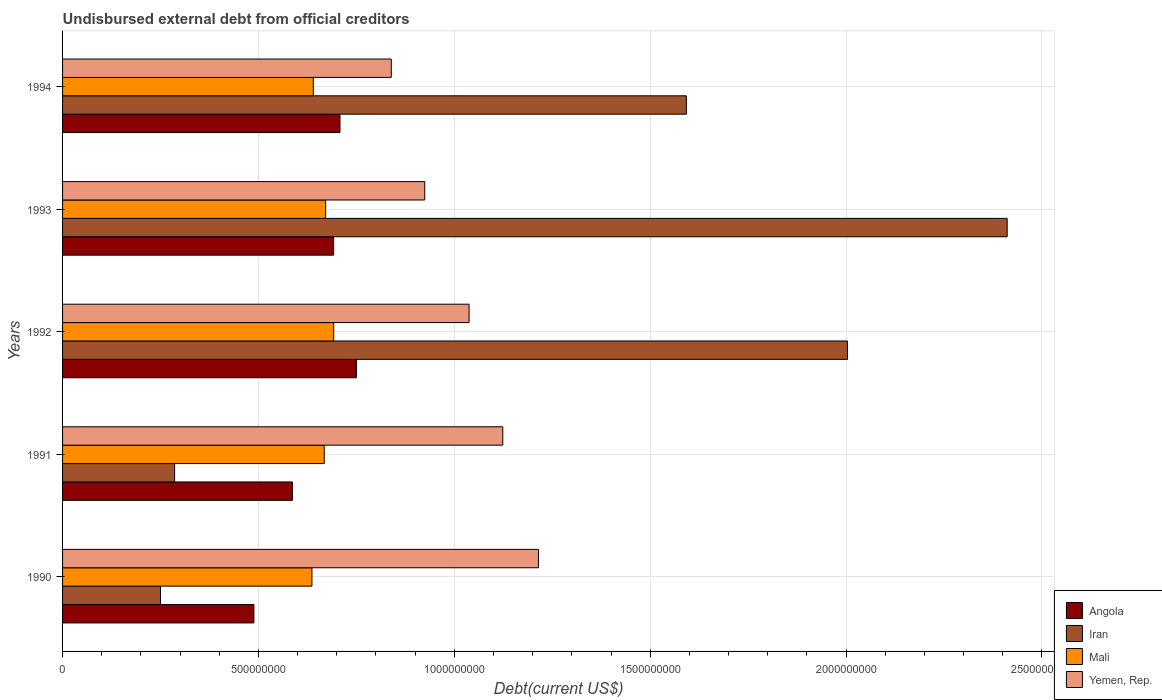How many different coloured bars are there?
Give a very brief answer. 4. How many groups of bars are there?
Make the answer very short. 5. How many bars are there on the 4th tick from the top?
Keep it short and to the point. 4. How many bars are there on the 3rd tick from the bottom?
Your answer should be very brief. 4. What is the label of the 4th group of bars from the top?
Your answer should be compact. 1991. What is the total debt in Mali in 1994?
Your answer should be compact. 6.40e+08. Across all years, what is the maximum total debt in Angola?
Your response must be concise. 7.50e+08. Across all years, what is the minimum total debt in Iran?
Ensure brevity in your answer.  2.50e+08. In which year was the total debt in Angola minimum?
Your answer should be very brief. 1990. What is the total total debt in Yemen, Rep. in the graph?
Give a very brief answer. 5.14e+09. What is the difference between the total debt in Iran in 1990 and that in 1993?
Keep it short and to the point. -2.16e+09. What is the difference between the total debt in Angola in 1992 and the total debt in Yemen, Rep. in 1991?
Make the answer very short. -3.74e+08. What is the average total debt in Angola per year?
Keep it short and to the point. 6.45e+08. In the year 1992, what is the difference between the total debt in Mali and total debt in Angola?
Provide a succinct answer. -5.78e+07. What is the ratio of the total debt in Iran in 1990 to that in 1991?
Offer a terse response. 0.87. Is the total debt in Mali in 1992 less than that in 1993?
Ensure brevity in your answer.  No. Is the difference between the total debt in Mali in 1991 and 1992 greater than the difference between the total debt in Angola in 1991 and 1992?
Offer a very short reply. Yes. What is the difference between the highest and the second highest total debt in Angola?
Your answer should be compact. 4.18e+07. What is the difference between the highest and the lowest total debt in Mali?
Ensure brevity in your answer.  5.56e+07. Is the sum of the total debt in Yemen, Rep. in 1990 and 1992 greater than the maximum total debt in Angola across all years?
Ensure brevity in your answer.  Yes. What does the 1st bar from the top in 1994 represents?
Offer a terse response. Yemen, Rep. What does the 1st bar from the bottom in 1991 represents?
Provide a short and direct response. Angola. Is it the case that in every year, the sum of the total debt in Angola and total debt in Yemen, Rep. is greater than the total debt in Iran?
Offer a terse response. No. How many bars are there?
Your response must be concise. 20. How many years are there in the graph?
Your response must be concise. 5. What is the difference between two consecutive major ticks on the X-axis?
Make the answer very short. 5.00e+08. Are the values on the major ticks of X-axis written in scientific E-notation?
Your answer should be compact. No. Does the graph contain any zero values?
Give a very brief answer. No. Does the graph contain grids?
Offer a terse response. Yes. Where does the legend appear in the graph?
Ensure brevity in your answer.  Bottom right. How are the legend labels stacked?
Keep it short and to the point. Vertical. What is the title of the graph?
Offer a very short reply. Undisbursed external debt from official creditors. Does "Equatorial Guinea" appear as one of the legend labels in the graph?
Offer a very short reply. No. What is the label or title of the X-axis?
Provide a succinct answer. Debt(current US$). What is the label or title of the Y-axis?
Your answer should be compact. Years. What is the Debt(current US$) in Angola in 1990?
Keep it short and to the point. 4.88e+08. What is the Debt(current US$) in Iran in 1990?
Provide a succinct answer. 2.50e+08. What is the Debt(current US$) in Mali in 1990?
Your answer should be compact. 6.37e+08. What is the Debt(current US$) in Yemen, Rep. in 1990?
Make the answer very short. 1.21e+09. What is the Debt(current US$) in Angola in 1991?
Offer a very short reply. 5.87e+08. What is the Debt(current US$) in Iran in 1991?
Offer a very short reply. 2.86e+08. What is the Debt(current US$) in Mali in 1991?
Offer a very short reply. 6.68e+08. What is the Debt(current US$) of Yemen, Rep. in 1991?
Your response must be concise. 1.12e+09. What is the Debt(current US$) in Angola in 1992?
Your answer should be very brief. 7.50e+08. What is the Debt(current US$) in Iran in 1992?
Offer a terse response. 2.00e+09. What is the Debt(current US$) of Mali in 1992?
Provide a succinct answer. 6.92e+08. What is the Debt(current US$) of Yemen, Rep. in 1992?
Make the answer very short. 1.04e+09. What is the Debt(current US$) in Angola in 1993?
Offer a terse response. 6.92e+08. What is the Debt(current US$) of Iran in 1993?
Keep it short and to the point. 2.41e+09. What is the Debt(current US$) of Mali in 1993?
Keep it short and to the point. 6.72e+08. What is the Debt(current US$) in Yemen, Rep. in 1993?
Make the answer very short. 9.25e+08. What is the Debt(current US$) in Angola in 1994?
Offer a very short reply. 7.08e+08. What is the Debt(current US$) in Iran in 1994?
Offer a very short reply. 1.59e+09. What is the Debt(current US$) of Mali in 1994?
Your answer should be very brief. 6.40e+08. What is the Debt(current US$) of Yemen, Rep. in 1994?
Your response must be concise. 8.39e+08. Across all years, what is the maximum Debt(current US$) of Angola?
Make the answer very short. 7.50e+08. Across all years, what is the maximum Debt(current US$) of Iran?
Give a very brief answer. 2.41e+09. Across all years, what is the maximum Debt(current US$) of Mali?
Ensure brevity in your answer.  6.92e+08. Across all years, what is the maximum Debt(current US$) of Yemen, Rep.?
Provide a short and direct response. 1.21e+09. Across all years, what is the minimum Debt(current US$) of Angola?
Keep it short and to the point. 4.88e+08. Across all years, what is the minimum Debt(current US$) in Iran?
Offer a terse response. 2.50e+08. Across all years, what is the minimum Debt(current US$) in Mali?
Your answer should be compact. 6.37e+08. Across all years, what is the minimum Debt(current US$) of Yemen, Rep.?
Provide a short and direct response. 8.39e+08. What is the total Debt(current US$) of Angola in the graph?
Your answer should be very brief. 3.22e+09. What is the total Debt(current US$) in Iran in the graph?
Give a very brief answer. 6.54e+09. What is the total Debt(current US$) in Mali in the graph?
Your answer should be compact. 3.31e+09. What is the total Debt(current US$) in Yemen, Rep. in the graph?
Make the answer very short. 5.14e+09. What is the difference between the Debt(current US$) of Angola in 1990 and that in 1991?
Provide a succinct answer. -9.83e+07. What is the difference between the Debt(current US$) of Iran in 1990 and that in 1991?
Give a very brief answer. -3.60e+07. What is the difference between the Debt(current US$) in Mali in 1990 and that in 1991?
Ensure brevity in your answer.  -3.14e+07. What is the difference between the Debt(current US$) of Yemen, Rep. in 1990 and that in 1991?
Your answer should be compact. 9.11e+07. What is the difference between the Debt(current US$) in Angola in 1990 and that in 1992?
Give a very brief answer. -2.62e+08. What is the difference between the Debt(current US$) of Iran in 1990 and that in 1992?
Your response must be concise. -1.75e+09. What is the difference between the Debt(current US$) in Mali in 1990 and that in 1992?
Offer a terse response. -5.56e+07. What is the difference between the Debt(current US$) of Yemen, Rep. in 1990 and that in 1992?
Your answer should be compact. 1.77e+08. What is the difference between the Debt(current US$) of Angola in 1990 and that in 1993?
Provide a succinct answer. -2.03e+08. What is the difference between the Debt(current US$) of Iran in 1990 and that in 1993?
Offer a very short reply. -2.16e+09. What is the difference between the Debt(current US$) in Mali in 1990 and that in 1993?
Offer a terse response. -3.50e+07. What is the difference between the Debt(current US$) of Yemen, Rep. in 1990 and that in 1993?
Your response must be concise. 2.90e+08. What is the difference between the Debt(current US$) in Angola in 1990 and that in 1994?
Give a very brief answer. -2.20e+08. What is the difference between the Debt(current US$) in Iran in 1990 and that in 1994?
Your answer should be very brief. -1.34e+09. What is the difference between the Debt(current US$) in Mali in 1990 and that in 1994?
Your answer should be compact. -3.48e+06. What is the difference between the Debt(current US$) of Yemen, Rep. in 1990 and that in 1994?
Offer a terse response. 3.76e+08. What is the difference between the Debt(current US$) in Angola in 1991 and that in 1992?
Your answer should be very brief. -1.63e+08. What is the difference between the Debt(current US$) in Iran in 1991 and that in 1992?
Make the answer very short. -1.72e+09. What is the difference between the Debt(current US$) in Mali in 1991 and that in 1992?
Keep it short and to the point. -2.41e+07. What is the difference between the Debt(current US$) in Yemen, Rep. in 1991 and that in 1992?
Offer a terse response. 8.60e+07. What is the difference between the Debt(current US$) of Angola in 1991 and that in 1993?
Offer a very short reply. -1.05e+08. What is the difference between the Debt(current US$) in Iran in 1991 and that in 1993?
Offer a very short reply. -2.13e+09. What is the difference between the Debt(current US$) in Mali in 1991 and that in 1993?
Your answer should be very brief. -3.56e+06. What is the difference between the Debt(current US$) of Yemen, Rep. in 1991 and that in 1993?
Ensure brevity in your answer.  1.99e+08. What is the difference between the Debt(current US$) in Angola in 1991 and that in 1994?
Your answer should be compact. -1.21e+08. What is the difference between the Debt(current US$) in Iran in 1991 and that in 1994?
Give a very brief answer. -1.31e+09. What is the difference between the Debt(current US$) of Mali in 1991 and that in 1994?
Ensure brevity in your answer.  2.80e+07. What is the difference between the Debt(current US$) in Yemen, Rep. in 1991 and that in 1994?
Your answer should be compact. 2.85e+08. What is the difference between the Debt(current US$) in Angola in 1992 and that in 1993?
Offer a terse response. 5.81e+07. What is the difference between the Debt(current US$) of Iran in 1992 and that in 1993?
Ensure brevity in your answer.  -4.08e+08. What is the difference between the Debt(current US$) of Mali in 1992 and that in 1993?
Provide a succinct answer. 2.06e+07. What is the difference between the Debt(current US$) of Yemen, Rep. in 1992 and that in 1993?
Give a very brief answer. 1.13e+08. What is the difference between the Debt(current US$) in Angola in 1992 and that in 1994?
Give a very brief answer. 4.18e+07. What is the difference between the Debt(current US$) in Iran in 1992 and that in 1994?
Give a very brief answer. 4.11e+08. What is the difference between the Debt(current US$) in Mali in 1992 and that in 1994?
Your answer should be very brief. 5.21e+07. What is the difference between the Debt(current US$) of Yemen, Rep. in 1992 and that in 1994?
Give a very brief answer. 1.99e+08. What is the difference between the Debt(current US$) of Angola in 1993 and that in 1994?
Provide a succinct answer. -1.63e+07. What is the difference between the Debt(current US$) of Iran in 1993 and that in 1994?
Give a very brief answer. 8.19e+08. What is the difference between the Debt(current US$) in Mali in 1993 and that in 1994?
Offer a terse response. 3.15e+07. What is the difference between the Debt(current US$) in Yemen, Rep. in 1993 and that in 1994?
Ensure brevity in your answer.  8.55e+07. What is the difference between the Debt(current US$) in Angola in 1990 and the Debt(current US$) in Iran in 1991?
Offer a very short reply. 2.02e+08. What is the difference between the Debt(current US$) in Angola in 1990 and the Debt(current US$) in Mali in 1991?
Make the answer very short. -1.80e+08. What is the difference between the Debt(current US$) in Angola in 1990 and the Debt(current US$) in Yemen, Rep. in 1991?
Make the answer very short. -6.35e+08. What is the difference between the Debt(current US$) of Iran in 1990 and the Debt(current US$) of Mali in 1991?
Your response must be concise. -4.18e+08. What is the difference between the Debt(current US$) in Iran in 1990 and the Debt(current US$) in Yemen, Rep. in 1991?
Your response must be concise. -8.74e+08. What is the difference between the Debt(current US$) in Mali in 1990 and the Debt(current US$) in Yemen, Rep. in 1991?
Keep it short and to the point. -4.87e+08. What is the difference between the Debt(current US$) of Angola in 1990 and the Debt(current US$) of Iran in 1992?
Give a very brief answer. -1.52e+09. What is the difference between the Debt(current US$) in Angola in 1990 and the Debt(current US$) in Mali in 1992?
Offer a terse response. -2.04e+08. What is the difference between the Debt(current US$) of Angola in 1990 and the Debt(current US$) of Yemen, Rep. in 1992?
Offer a very short reply. -5.49e+08. What is the difference between the Debt(current US$) in Iran in 1990 and the Debt(current US$) in Mali in 1992?
Offer a very short reply. -4.42e+08. What is the difference between the Debt(current US$) in Iran in 1990 and the Debt(current US$) in Yemen, Rep. in 1992?
Provide a succinct answer. -7.88e+08. What is the difference between the Debt(current US$) of Mali in 1990 and the Debt(current US$) of Yemen, Rep. in 1992?
Provide a succinct answer. -4.01e+08. What is the difference between the Debt(current US$) in Angola in 1990 and the Debt(current US$) in Iran in 1993?
Provide a short and direct response. -1.92e+09. What is the difference between the Debt(current US$) of Angola in 1990 and the Debt(current US$) of Mali in 1993?
Offer a terse response. -1.83e+08. What is the difference between the Debt(current US$) in Angola in 1990 and the Debt(current US$) in Yemen, Rep. in 1993?
Offer a terse response. -4.36e+08. What is the difference between the Debt(current US$) of Iran in 1990 and the Debt(current US$) of Mali in 1993?
Give a very brief answer. -4.22e+08. What is the difference between the Debt(current US$) in Iran in 1990 and the Debt(current US$) in Yemen, Rep. in 1993?
Provide a short and direct response. -6.75e+08. What is the difference between the Debt(current US$) of Mali in 1990 and the Debt(current US$) of Yemen, Rep. in 1993?
Offer a very short reply. -2.88e+08. What is the difference between the Debt(current US$) in Angola in 1990 and the Debt(current US$) in Iran in 1994?
Your answer should be compact. -1.10e+09. What is the difference between the Debt(current US$) in Angola in 1990 and the Debt(current US$) in Mali in 1994?
Offer a terse response. -1.52e+08. What is the difference between the Debt(current US$) of Angola in 1990 and the Debt(current US$) of Yemen, Rep. in 1994?
Make the answer very short. -3.51e+08. What is the difference between the Debt(current US$) of Iran in 1990 and the Debt(current US$) of Mali in 1994?
Ensure brevity in your answer.  -3.90e+08. What is the difference between the Debt(current US$) in Iran in 1990 and the Debt(current US$) in Yemen, Rep. in 1994?
Make the answer very short. -5.89e+08. What is the difference between the Debt(current US$) of Mali in 1990 and the Debt(current US$) of Yemen, Rep. in 1994?
Keep it short and to the point. -2.03e+08. What is the difference between the Debt(current US$) in Angola in 1991 and the Debt(current US$) in Iran in 1992?
Give a very brief answer. -1.42e+09. What is the difference between the Debt(current US$) in Angola in 1991 and the Debt(current US$) in Mali in 1992?
Ensure brevity in your answer.  -1.05e+08. What is the difference between the Debt(current US$) of Angola in 1991 and the Debt(current US$) of Yemen, Rep. in 1992?
Offer a terse response. -4.51e+08. What is the difference between the Debt(current US$) of Iran in 1991 and the Debt(current US$) of Mali in 1992?
Your answer should be very brief. -4.06e+08. What is the difference between the Debt(current US$) in Iran in 1991 and the Debt(current US$) in Yemen, Rep. in 1992?
Your answer should be compact. -7.52e+08. What is the difference between the Debt(current US$) in Mali in 1991 and the Debt(current US$) in Yemen, Rep. in 1992?
Your response must be concise. -3.70e+08. What is the difference between the Debt(current US$) of Angola in 1991 and the Debt(current US$) of Iran in 1993?
Your answer should be compact. -1.82e+09. What is the difference between the Debt(current US$) of Angola in 1991 and the Debt(current US$) of Mali in 1993?
Offer a very short reply. -8.48e+07. What is the difference between the Debt(current US$) of Angola in 1991 and the Debt(current US$) of Yemen, Rep. in 1993?
Offer a terse response. -3.38e+08. What is the difference between the Debt(current US$) in Iran in 1991 and the Debt(current US$) in Mali in 1993?
Your response must be concise. -3.86e+08. What is the difference between the Debt(current US$) of Iran in 1991 and the Debt(current US$) of Yemen, Rep. in 1993?
Keep it short and to the point. -6.39e+08. What is the difference between the Debt(current US$) in Mali in 1991 and the Debt(current US$) in Yemen, Rep. in 1993?
Your response must be concise. -2.57e+08. What is the difference between the Debt(current US$) of Angola in 1991 and the Debt(current US$) of Iran in 1994?
Offer a terse response. -1.01e+09. What is the difference between the Debt(current US$) in Angola in 1991 and the Debt(current US$) in Mali in 1994?
Your answer should be compact. -5.33e+07. What is the difference between the Debt(current US$) of Angola in 1991 and the Debt(current US$) of Yemen, Rep. in 1994?
Keep it short and to the point. -2.52e+08. What is the difference between the Debt(current US$) of Iran in 1991 and the Debt(current US$) of Mali in 1994?
Keep it short and to the point. -3.54e+08. What is the difference between the Debt(current US$) of Iran in 1991 and the Debt(current US$) of Yemen, Rep. in 1994?
Make the answer very short. -5.53e+08. What is the difference between the Debt(current US$) of Mali in 1991 and the Debt(current US$) of Yemen, Rep. in 1994?
Ensure brevity in your answer.  -1.71e+08. What is the difference between the Debt(current US$) in Angola in 1992 and the Debt(current US$) in Iran in 1993?
Keep it short and to the point. -1.66e+09. What is the difference between the Debt(current US$) of Angola in 1992 and the Debt(current US$) of Mali in 1993?
Keep it short and to the point. 7.84e+07. What is the difference between the Debt(current US$) in Angola in 1992 and the Debt(current US$) in Yemen, Rep. in 1993?
Your response must be concise. -1.75e+08. What is the difference between the Debt(current US$) of Iran in 1992 and the Debt(current US$) of Mali in 1993?
Offer a terse response. 1.33e+09. What is the difference between the Debt(current US$) in Iran in 1992 and the Debt(current US$) in Yemen, Rep. in 1993?
Provide a succinct answer. 1.08e+09. What is the difference between the Debt(current US$) in Mali in 1992 and the Debt(current US$) in Yemen, Rep. in 1993?
Ensure brevity in your answer.  -2.32e+08. What is the difference between the Debt(current US$) of Angola in 1992 and the Debt(current US$) of Iran in 1994?
Make the answer very short. -8.42e+08. What is the difference between the Debt(current US$) of Angola in 1992 and the Debt(current US$) of Mali in 1994?
Your response must be concise. 1.10e+08. What is the difference between the Debt(current US$) in Angola in 1992 and the Debt(current US$) in Yemen, Rep. in 1994?
Offer a terse response. -8.91e+07. What is the difference between the Debt(current US$) of Iran in 1992 and the Debt(current US$) of Mali in 1994?
Ensure brevity in your answer.  1.36e+09. What is the difference between the Debt(current US$) in Iran in 1992 and the Debt(current US$) in Yemen, Rep. in 1994?
Provide a short and direct response. 1.16e+09. What is the difference between the Debt(current US$) in Mali in 1992 and the Debt(current US$) in Yemen, Rep. in 1994?
Offer a terse response. -1.47e+08. What is the difference between the Debt(current US$) of Angola in 1993 and the Debt(current US$) of Iran in 1994?
Your answer should be compact. -9.00e+08. What is the difference between the Debt(current US$) in Angola in 1993 and the Debt(current US$) in Mali in 1994?
Your response must be concise. 5.18e+07. What is the difference between the Debt(current US$) in Angola in 1993 and the Debt(current US$) in Yemen, Rep. in 1994?
Your answer should be compact. -1.47e+08. What is the difference between the Debt(current US$) in Iran in 1993 and the Debt(current US$) in Mali in 1994?
Offer a terse response. 1.77e+09. What is the difference between the Debt(current US$) of Iran in 1993 and the Debt(current US$) of Yemen, Rep. in 1994?
Offer a very short reply. 1.57e+09. What is the difference between the Debt(current US$) of Mali in 1993 and the Debt(current US$) of Yemen, Rep. in 1994?
Your answer should be compact. -1.68e+08. What is the average Debt(current US$) in Angola per year?
Offer a terse response. 6.45e+08. What is the average Debt(current US$) in Iran per year?
Provide a succinct answer. 1.31e+09. What is the average Debt(current US$) of Mali per year?
Make the answer very short. 6.62e+08. What is the average Debt(current US$) in Yemen, Rep. per year?
Give a very brief answer. 1.03e+09. In the year 1990, what is the difference between the Debt(current US$) in Angola and Debt(current US$) in Iran?
Your response must be concise. 2.38e+08. In the year 1990, what is the difference between the Debt(current US$) in Angola and Debt(current US$) in Mali?
Your answer should be very brief. -1.48e+08. In the year 1990, what is the difference between the Debt(current US$) of Angola and Debt(current US$) of Yemen, Rep.?
Provide a short and direct response. -7.26e+08. In the year 1990, what is the difference between the Debt(current US$) in Iran and Debt(current US$) in Mali?
Make the answer very short. -3.87e+08. In the year 1990, what is the difference between the Debt(current US$) in Iran and Debt(current US$) in Yemen, Rep.?
Give a very brief answer. -9.65e+08. In the year 1990, what is the difference between the Debt(current US$) of Mali and Debt(current US$) of Yemen, Rep.?
Give a very brief answer. -5.78e+08. In the year 1991, what is the difference between the Debt(current US$) in Angola and Debt(current US$) in Iran?
Your answer should be very brief. 3.01e+08. In the year 1991, what is the difference between the Debt(current US$) of Angola and Debt(current US$) of Mali?
Offer a very short reply. -8.13e+07. In the year 1991, what is the difference between the Debt(current US$) in Angola and Debt(current US$) in Yemen, Rep.?
Your answer should be very brief. -5.37e+08. In the year 1991, what is the difference between the Debt(current US$) in Iran and Debt(current US$) in Mali?
Your response must be concise. -3.82e+08. In the year 1991, what is the difference between the Debt(current US$) in Iran and Debt(current US$) in Yemen, Rep.?
Your answer should be compact. -8.38e+08. In the year 1991, what is the difference between the Debt(current US$) in Mali and Debt(current US$) in Yemen, Rep.?
Keep it short and to the point. -4.56e+08. In the year 1992, what is the difference between the Debt(current US$) in Angola and Debt(current US$) in Iran?
Offer a very short reply. -1.25e+09. In the year 1992, what is the difference between the Debt(current US$) in Angola and Debt(current US$) in Mali?
Provide a short and direct response. 5.78e+07. In the year 1992, what is the difference between the Debt(current US$) of Angola and Debt(current US$) of Yemen, Rep.?
Give a very brief answer. -2.88e+08. In the year 1992, what is the difference between the Debt(current US$) of Iran and Debt(current US$) of Mali?
Your answer should be very brief. 1.31e+09. In the year 1992, what is the difference between the Debt(current US$) in Iran and Debt(current US$) in Yemen, Rep.?
Ensure brevity in your answer.  9.66e+08. In the year 1992, what is the difference between the Debt(current US$) of Mali and Debt(current US$) of Yemen, Rep.?
Ensure brevity in your answer.  -3.46e+08. In the year 1993, what is the difference between the Debt(current US$) of Angola and Debt(current US$) of Iran?
Offer a terse response. -1.72e+09. In the year 1993, what is the difference between the Debt(current US$) of Angola and Debt(current US$) of Mali?
Offer a very short reply. 2.03e+07. In the year 1993, what is the difference between the Debt(current US$) in Angola and Debt(current US$) in Yemen, Rep.?
Keep it short and to the point. -2.33e+08. In the year 1993, what is the difference between the Debt(current US$) of Iran and Debt(current US$) of Mali?
Your answer should be compact. 1.74e+09. In the year 1993, what is the difference between the Debt(current US$) of Iran and Debt(current US$) of Yemen, Rep.?
Give a very brief answer. 1.49e+09. In the year 1993, what is the difference between the Debt(current US$) in Mali and Debt(current US$) in Yemen, Rep.?
Make the answer very short. -2.53e+08. In the year 1994, what is the difference between the Debt(current US$) in Angola and Debt(current US$) in Iran?
Your response must be concise. -8.84e+08. In the year 1994, what is the difference between the Debt(current US$) of Angola and Debt(current US$) of Mali?
Keep it short and to the point. 6.81e+07. In the year 1994, what is the difference between the Debt(current US$) in Angola and Debt(current US$) in Yemen, Rep.?
Offer a very short reply. -1.31e+08. In the year 1994, what is the difference between the Debt(current US$) of Iran and Debt(current US$) of Mali?
Make the answer very short. 9.52e+08. In the year 1994, what is the difference between the Debt(current US$) in Iran and Debt(current US$) in Yemen, Rep.?
Provide a succinct answer. 7.53e+08. In the year 1994, what is the difference between the Debt(current US$) of Mali and Debt(current US$) of Yemen, Rep.?
Your response must be concise. -1.99e+08. What is the ratio of the Debt(current US$) of Angola in 1990 to that in 1991?
Give a very brief answer. 0.83. What is the ratio of the Debt(current US$) in Iran in 1990 to that in 1991?
Make the answer very short. 0.87. What is the ratio of the Debt(current US$) in Mali in 1990 to that in 1991?
Give a very brief answer. 0.95. What is the ratio of the Debt(current US$) of Yemen, Rep. in 1990 to that in 1991?
Provide a succinct answer. 1.08. What is the ratio of the Debt(current US$) in Angola in 1990 to that in 1992?
Give a very brief answer. 0.65. What is the ratio of the Debt(current US$) in Iran in 1990 to that in 1992?
Your answer should be compact. 0.12. What is the ratio of the Debt(current US$) in Mali in 1990 to that in 1992?
Provide a succinct answer. 0.92. What is the ratio of the Debt(current US$) of Yemen, Rep. in 1990 to that in 1992?
Offer a very short reply. 1.17. What is the ratio of the Debt(current US$) in Angola in 1990 to that in 1993?
Your answer should be compact. 0.71. What is the ratio of the Debt(current US$) of Iran in 1990 to that in 1993?
Give a very brief answer. 0.1. What is the ratio of the Debt(current US$) in Mali in 1990 to that in 1993?
Keep it short and to the point. 0.95. What is the ratio of the Debt(current US$) of Yemen, Rep. in 1990 to that in 1993?
Your response must be concise. 1.31. What is the ratio of the Debt(current US$) of Angola in 1990 to that in 1994?
Your response must be concise. 0.69. What is the ratio of the Debt(current US$) in Iran in 1990 to that in 1994?
Your response must be concise. 0.16. What is the ratio of the Debt(current US$) in Mali in 1990 to that in 1994?
Provide a short and direct response. 0.99. What is the ratio of the Debt(current US$) in Yemen, Rep. in 1990 to that in 1994?
Make the answer very short. 1.45. What is the ratio of the Debt(current US$) in Angola in 1991 to that in 1992?
Your answer should be very brief. 0.78. What is the ratio of the Debt(current US$) in Iran in 1991 to that in 1992?
Your answer should be very brief. 0.14. What is the ratio of the Debt(current US$) of Mali in 1991 to that in 1992?
Provide a short and direct response. 0.97. What is the ratio of the Debt(current US$) in Yemen, Rep. in 1991 to that in 1992?
Offer a terse response. 1.08. What is the ratio of the Debt(current US$) of Angola in 1991 to that in 1993?
Make the answer very short. 0.85. What is the ratio of the Debt(current US$) in Iran in 1991 to that in 1993?
Give a very brief answer. 0.12. What is the ratio of the Debt(current US$) in Mali in 1991 to that in 1993?
Offer a very short reply. 0.99. What is the ratio of the Debt(current US$) in Yemen, Rep. in 1991 to that in 1993?
Ensure brevity in your answer.  1.22. What is the ratio of the Debt(current US$) in Angola in 1991 to that in 1994?
Keep it short and to the point. 0.83. What is the ratio of the Debt(current US$) of Iran in 1991 to that in 1994?
Offer a terse response. 0.18. What is the ratio of the Debt(current US$) in Mali in 1991 to that in 1994?
Give a very brief answer. 1.04. What is the ratio of the Debt(current US$) in Yemen, Rep. in 1991 to that in 1994?
Your response must be concise. 1.34. What is the ratio of the Debt(current US$) in Angola in 1992 to that in 1993?
Your answer should be compact. 1.08. What is the ratio of the Debt(current US$) of Iran in 1992 to that in 1993?
Provide a short and direct response. 0.83. What is the ratio of the Debt(current US$) in Mali in 1992 to that in 1993?
Your answer should be very brief. 1.03. What is the ratio of the Debt(current US$) of Yemen, Rep. in 1992 to that in 1993?
Offer a very short reply. 1.12. What is the ratio of the Debt(current US$) of Angola in 1992 to that in 1994?
Provide a succinct answer. 1.06. What is the ratio of the Debt(current US$) in Iran in 1992 to that in 1994?
Offer a terse response. 1.26. What is the ratio of the Debt(current US$) of Mali in 1992 to that in 1994?
Give a very brief answer. 1.08. What is the ratio of the Debt(current US$) in Yemen, Rep. in 1992 to that in 1994?
Give a very brief answer. 1.24. What is the ratio of the Debt(current US$) in Angola in 1993 to that in 1994?
Give a very brief answer. 0.98. What is the ratio of the Debt(current US$) of Iran in 1993 to that in 1994?
Make the answer very short. 1.51. What is the ratio of the Debt(current US$) in Mali in 1993 to that in 1994?
Offer a terse response. 1.05. What is the ratio of the Debt(current US$) in Yemen, Rep. in 1993 to that in 1994?
Your response must be concise. 1.1. What is the difference between the highest and the second highest Debt(current US$) in Angola?
Offer a terse response. 4.18e+07. What is the difference between the highest and the second highest Debt(current US$) of Iran?
Your answer should be very brief. 4.08e+08. What is the difference between the highest and the second highest Debt(current US$) in Mali?
Offer a terse response. 2.06e+07. What is the difference between the highest and the second highest Debt(current US$) of Yemen, Rep.?
Offer a terse response. 9.11e+07. What is the difference between the highest and the lowest Debt(current US$) of Angola?
Offer a terse response. 2.62e+08. What is the difference between the highest and the lowest Debt(current US$) in Iran?
Give a very brief answer. 2.16e+09. What is the difference between the highest and the lowest Debt(current US$) in Mali?
Keep it short and to the point. 5.56e+07. What is the difference between the highest and the lowest Debt(current US$) in Yemen, Rep.?
Your answer should be very brief. 3.76e+08. 